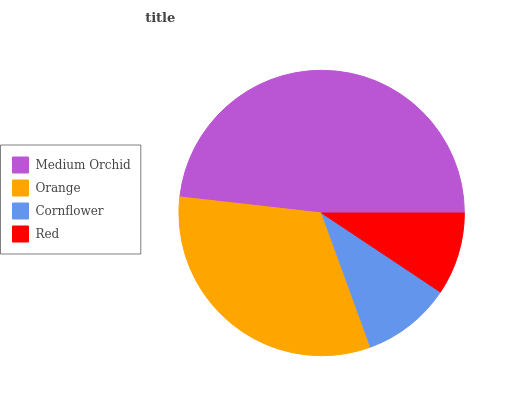Is Red the minimum?
Answer yes or no. Yes. Is Medium Orchid the maximum?
Answer yes or no. Yes. Is Orange the minimum?
Answer yes or no. No. Is Orange the maximum?
Answer yes or no. No. Is Medium Orchid greater than Orange?
Answer yes or no. Yes. Is Orange less than Medium Orchid?
Answer yes or no. Yes. Is Orange greater than Medium Orchid?
Answer yes or no. No. Is Medium Orchid less than Orange?
Answer yes or no. No. Is Orange the high median?
Answer yes or no. Yes. Is Cornflower the low median?
Answer yes or no. Yes. Is Medium Orchid the high median?
Answer yes or no. No. Is Medium Orchid the low median?
Answer yes or no. No. 